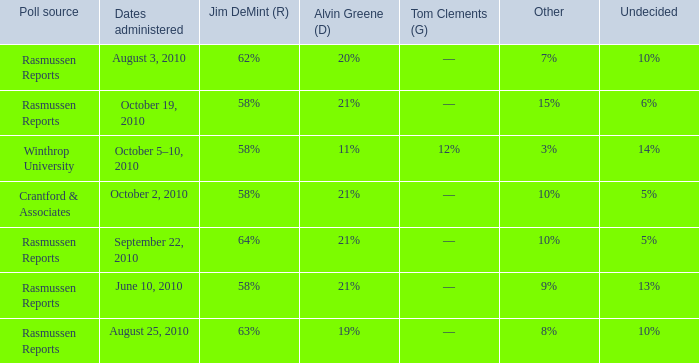What was the vote for Alvin Green when Jim DeMint was 62%? 20%. 